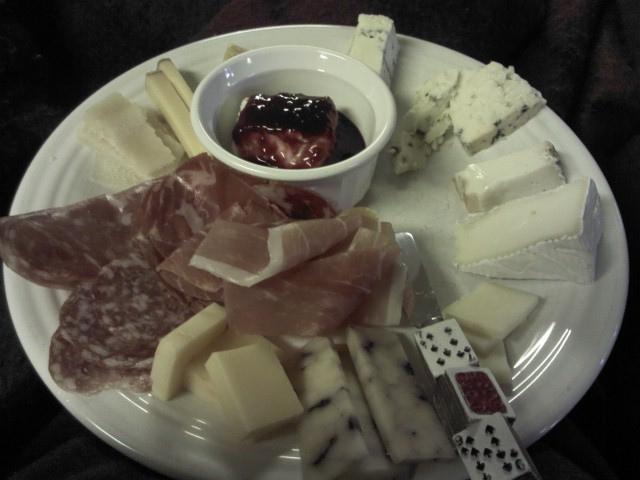How many spoons are on this plate?
Give a very brief answer. 0. 